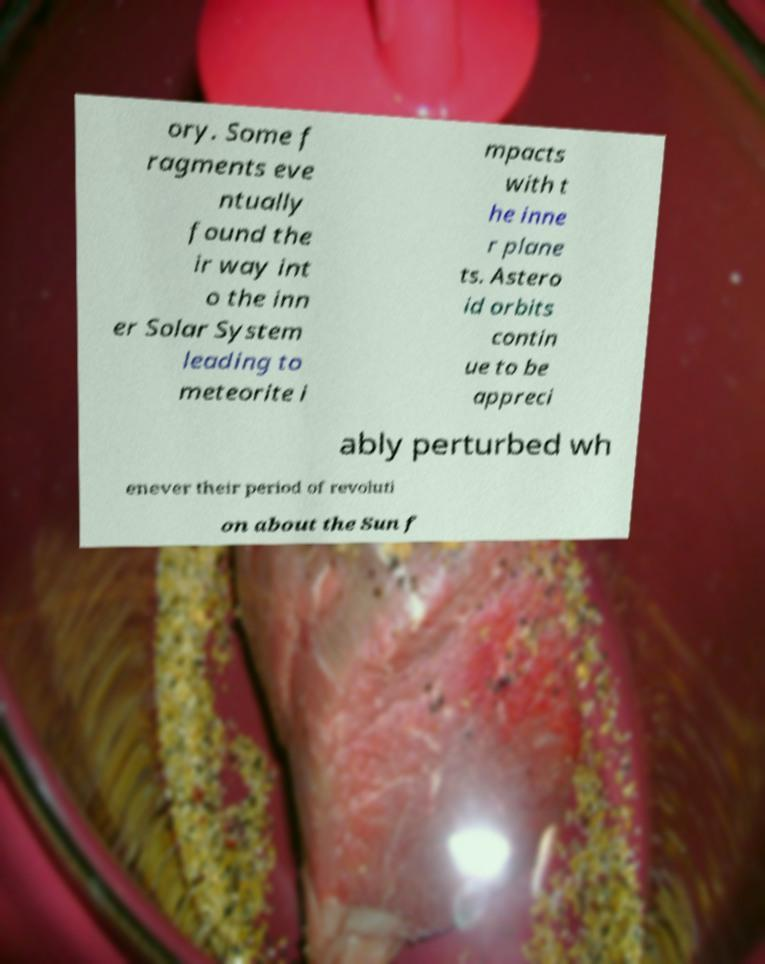I need the written content from this picture converted into text. Can you do that? ory. Some f ragments eve ntually found the ir way int o the inn er Solar System leading to meteorite i mpacts with t he inne r plane ts. Astero id orbits contin ue to be appreci ably perturbed wh enever their period of revoluti on about the Sun f 